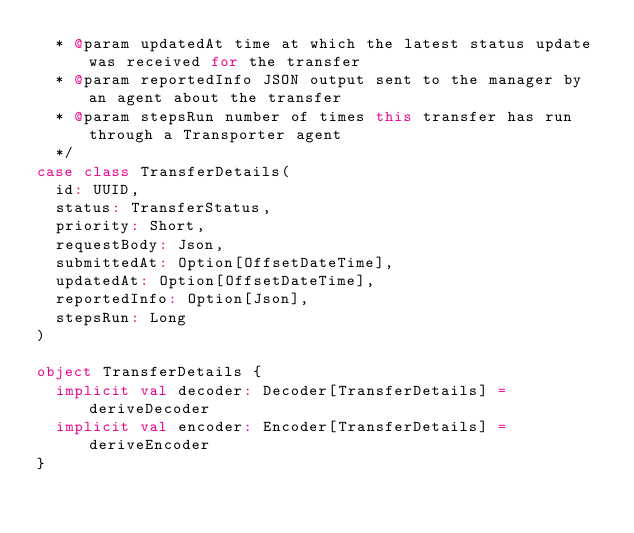<code> <loc_0><loc_0><loc_500><loc_500><_Scala_>  * @param updatedAt time at which the latest status update was received for the transfer
  * @param reportedInfo JSON output sent to the manager by an agent about the transfer
  * @param stepsRun number of times this transfer has run through a Transporter agent
  */
case class TransferDetails(
  id: UUID,
  status: TransferStatus,
  priority: Short,
  requestBody: Json,
  submittedAt: Option[OffsetDateTime],
  updatedAt: Option[OffsetDateTime],
  reportedInfo: Option[Json],
  stepsRun: Long
)

object TransferDetails {
  implicit val decoder: Decoder[TransferDetails] = deriveDecoder
  implicit val encoder: Encoder[TransferDetails] = deriveEncoder
}
</code> 